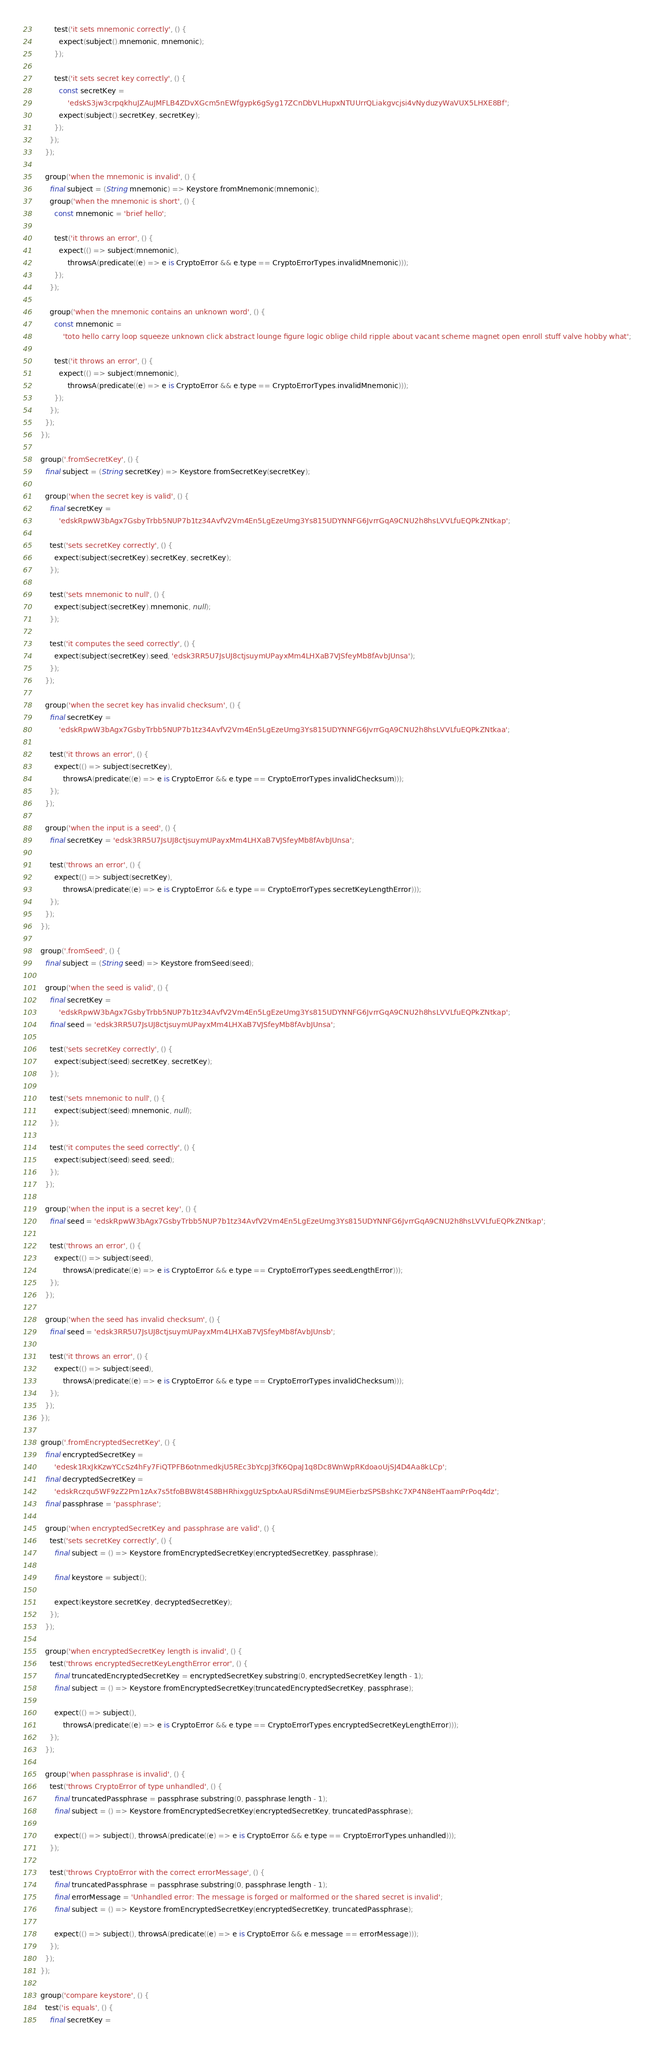Convert code to text. <code><loc_0><loc_0><loc_500><loc_500><_Dart_>        test('it sets mnemonic correctly', () {
          expect(subject().mnemonic, mnemonic);
        });

        test('it sets secret key correctly', () {
          const secretKey =
              'edskS3jw3crpqkhuJZAuJMFLB4ZDvXGcm5nEWfgypk6gSyg17ZCnDbVLHupxNTUUrrQLiakgvcjsi4vNyduzyWaVUX5LHXE8Bf';
          expect(subject().secretKey, secretKey);
        });
      });
    });

    group('when the mnemonic is invalid', () {
      final subject = (String mnemonic) => Keystore.fromMnemonic(mnemonic);
      group('when the mnemonic is short', () {
        const mnemonic = 'brief hello';

        test('it throws an error', () {
          expect(() => subject(mnemonic),
              throwsA(predicate((e) => e is CryptoError && e.type == CryptoErrorTypes.invalidMnemonic)));
        });
      });

      group('when the mnemonic contains an unknown word', () {
        const mnemonic =
            'toto hello carry loop squeeze unknown click abstract lounge figure logic oblige child ripple about vacant scheme magnet open enroll stuff valve hobby what';

        test('it throws an error', () {
          expect(() => subject(mnemonic),
              throwsA(predicate((e) => e is CryptoError && e.type == CryptoErrorTypes.invalidMnemonic)));
        });
      });
    });
  });

  group('.fromSecretKey', () {
    final subject = (String secretKey) => Keystore.fromSecretKey(secretKey);

    group('when the secret key is valid', () {
      final secretKey =
          'edskRpwW3bAgx7GsbyTrbb5NUP7b1tz34AvfV2Vm4En5LgEzeUmg3Ys815UDYNNFG6JvrrGqA9CNU2h8hsLVVLfuEQPkZNtkap';

      test('sets secretKey correctly', () {
        expect(subject(secretKey).secretKey, secretKey);
      });

      test('sets mnemonic to null', () {
        expect(subject(secretKey).mnemonic, null);
      });

      test('it computes the seed correctly', () {
        expect(subject(secretKey).seed, 'edsk3RR5U7JsUJ8ctjsuymUPayxMm4LHXaB7VJSfeyMb8fAvbJUnsa');
      });
    });

    group('when the secret key has invalid checksum', () {
      final secretKey =
          'edskRpwW3bAgx7GsbyTrbb5NUP7b1tz34AvfV2Vm4En5LgEzeUmg3Ys815UDYNNFG6JvrrGqA9CNU2h8hsLVVLfuEQPkZNtkaa';

      test('it throws an error', () {
        expect(() => subject(secretKey),
            throwsA(predicate((e) => e is CryptoError && e.type == CryptoErrorTypes.invalidChecksum)));
      });
    });

    group('when the input is a seed', () {
      final secretKey = 'edsk3RR5U7JsUJ8ctjsuymUPayxMm4LHXaB7VJSfeyMb8fAvbJUnsa';

      test('throws an error', () {
        expect(() => subject(secretKey),
            throwsA(predicate((e) => e is CryptoError && e.type == CryptoErrorTypes.secretKeyLengthError)));
      });
    });
  });

  group('.fromSeed', () {
    final subject = (String seed) => Keystore.fromSeed(seed);

    group('when the seed is valid', () {
      final secretKey =
          'edskRpwW3bAgx7GsbyTrbb5NUP7b1tz34AvfV2Vm4En5LgEzeUmg3Ys815UDYNNFG6JvrrGqA9CNU2h8hsLVVLfuEQPkZNtkap';
      final seed = 'edsk3RR5U7JsUJ8ctjsuymUPayxMm4LHXaB7VJSfeyMb8fAvbJUnsa';

      test('sets secretKey correctly', () {
        expect(subject(seed).secretKey, secretKey);
      });

      test('sets mnemonic to null', () {
        expect(subject(seed).mnemonic, null);
      });

      test('it computes the seed correctly', () {
        expect(subject(seed).seed, seed);
      });
    });

    group('when the input is a secret key', () {
      final seed = 'edskRpwW3bAgx7GsbyTrbb5NUP7b1tz34AvfV2Vm4En5LgEzeUmg3Ys815UDYNNFG6JvrrGqA9CNU2h8hsLVVLfuEQPkZNtkap';

      test('throws an error', () {
        expect(() => subject(seed),
            throwsA(predicate((e) => e is CryptoError && e.type == CryptoErrorTypes.seedLengthError)));
      });
    });

    group('when the seed has invalid checksum', () {
      final seed = 'edsk3RR5U7JsUJ8ctjsuymUPayxMm4LHXaB7VJSfeyMb8fAvbJUnsb';

      test('it throws an error', () {
        expect(() => subject(seed),
            throwsA(predicate((e) => e is CryptoError && e.type == CryptoErrorTypes.invalidChecksum)));
      });
    });
  });

  group('.fromEncryptedSecretKey', () {
    final encryptedSecretKey =
        'edesk1RxJkKzwYCcSz4hFy7FiQTPFB6otnmedkjU5REc3bYcpJ3fK6QpaJ1q8Dc8WnWpRKdoaoUjSJ4D4Aa8kLCp';
    final decryptedSecretKey =
        'edskRczqu5WF9zZ2Pm1zAx7s5tfoBBW8t4S8BHRhixggUzSptxAaURSdiNmsE9UMEierbzSPSBshKc7XP4N8eHTaamPrPoq4dz';
    final passphrase = 'passphrase';

    group('when encryptedSecretKey and passphrase are valid', () {
      test('sets secretKey correctly', () {
        final subject = () => Keystore.fromEncryptedSecretKey(encryptedSecretKey, passphrase);

        final keystore = subject();

        expect(keystore.secretKey, decryptedSecretKey);
      });
    });

    group('when encryptedSecretKey length is invalid', () {
      test('throws encryptedSecretKeyLengthError error', () {
        final truncatedEncryptedSecretKey = encryptedSecretKey.substring(0, encryptedSecretKey.length - 1);
        final subject = () => Keystore.fromEncryptedSecretKey(truncatedEncryptedSecretKey, passphrase);

        expect(() => subject(),
            throwsA(predicate((e) => e is CryptoError && e.type == CryptoErrorTypes.encryptedSecretKeyLengthError)));
      });
    });

    group('when passphrase is invalid', () {
      test('throws CryptoError of type unhandled', () {
        final truncatedPassphrase = passphrase.substring(0, passphrase.length - 1);
        final subject = () => Keystore.fromEncryptedSecretKey(encryptedSecretKey, truncatedPassphrase);

        expect(() => subject(), throwsA(predicate((e) => e is CryptoError && e.type == CryptoErrorTypes.unhandled)));
      });

      test('throws CryptoError with the correct errorMessage', () {
        final truncatedPassphrase = passphrase.substring(0, passphrase.length - 1);
        final errorMessage = 'Unhandled error: The message is forged or malformed or the shared secret is invalid';
        final subject = () => Keystore.fromEncryptedSecretKey(encryptedSecretKey, truncatedPassphrase);

        expect(() => subject(), throwsA(predicate((e) => e is CryptoError && e.message == errorMessage)));
      });
    });
  });

  group('compare keystore', () {
    test('is equals', () {
      final secretKey =</code> 